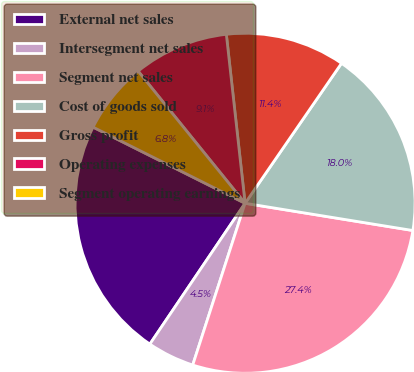Convert chart. <chart><loc_0><loc_0><loc_500><loc_500><pie_chart><fcel>External net sales<fcel>Intersegment net sales<fcel>Segment net sales<fcel>Cost of goods sold<fcel>Gross profit<fcel>Operating expenses<fcel>Segment operating earnings<nl><fcel>22.93%<fcel>4.48%<fcel>27.42%<fcel>17.96%<fcel>11.36%<fcel>9.07%<fcel>6.78%<nl></chart> 